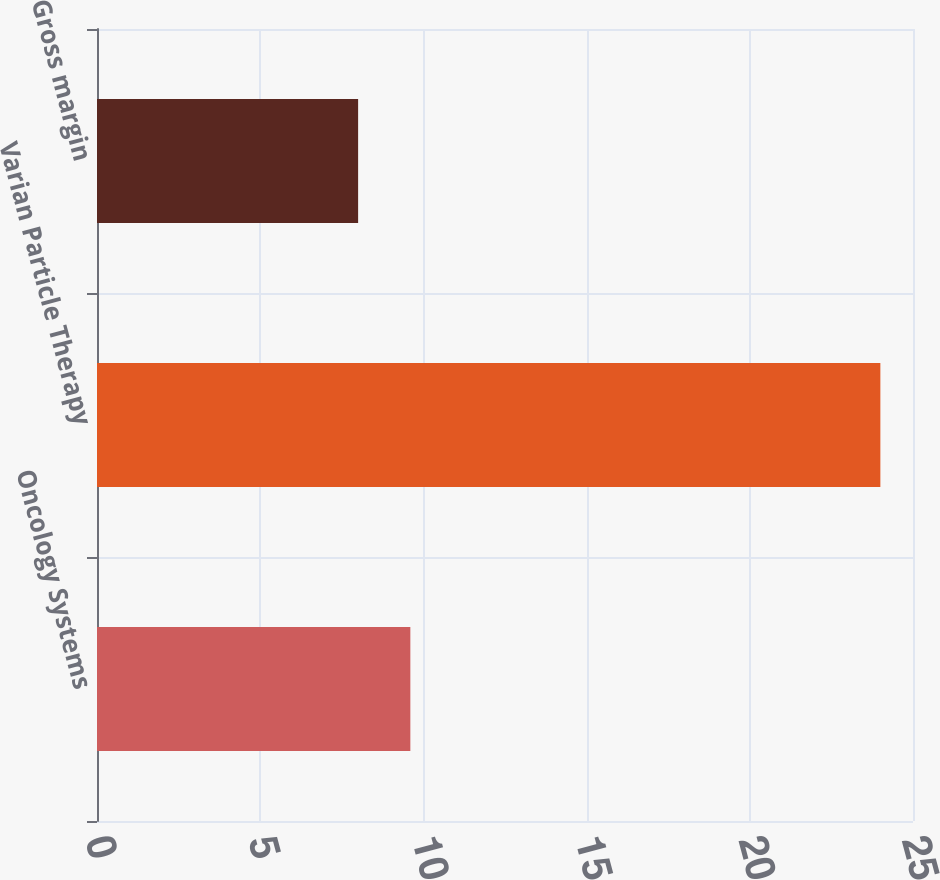Convert chart. <chart><loc_0><loc_0><loc_500><loc_500><bar_chart><fcel>Oncology Systems<fcel>Varian Particle Therapy<fcel>Gross margin<nl><fcel>9.6<fcel>24<fcel>8<nl></chart> 